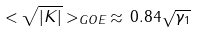<formula> <loc_0><loc_0><loc_500><loc_500>< \sqrt { | K | } > _ { G O E } \, \approx \, 0 . 8 4 \sqrt { \gamma _ { 1 } }</formula> 